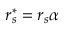<formula> <loc_0><loc_0><loc_500><loc_500>r _ { s } ^ { * } = r _ { s } \alpha</formula> 